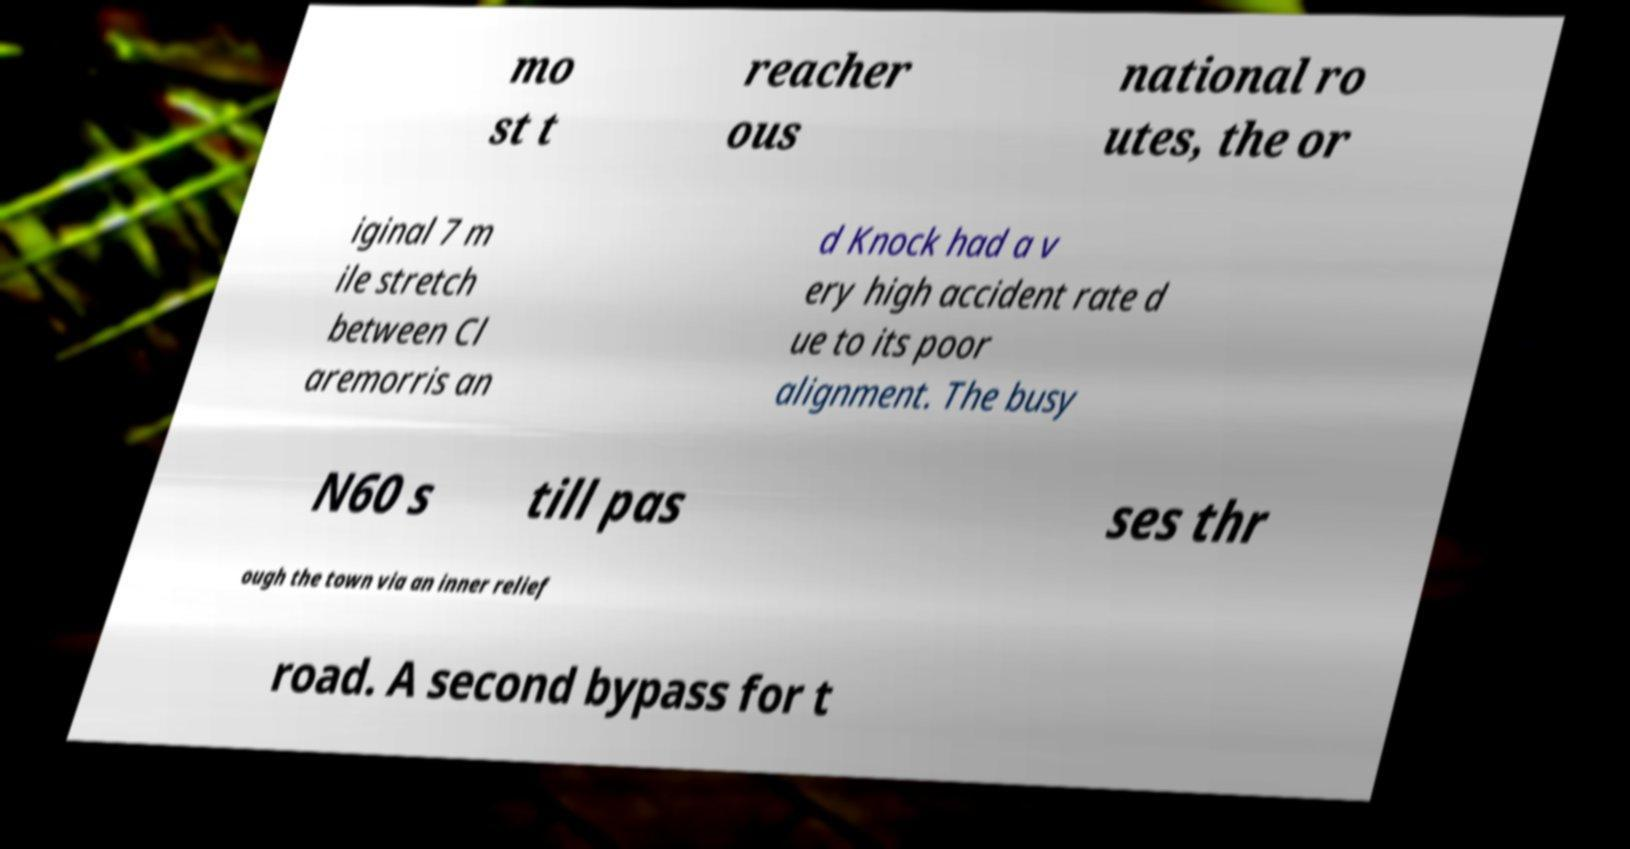I need the written content from this picture converted into text. Can you do that? mo st t reacher ous national ro utes, the or iginal 7 m ile stretch between Cl aremorris an d Knock had a v ery high accident rate d ue to its poor alignment. The busy N60 s till pas ses thr ough the town via an inner relief road. A second bypass for t 